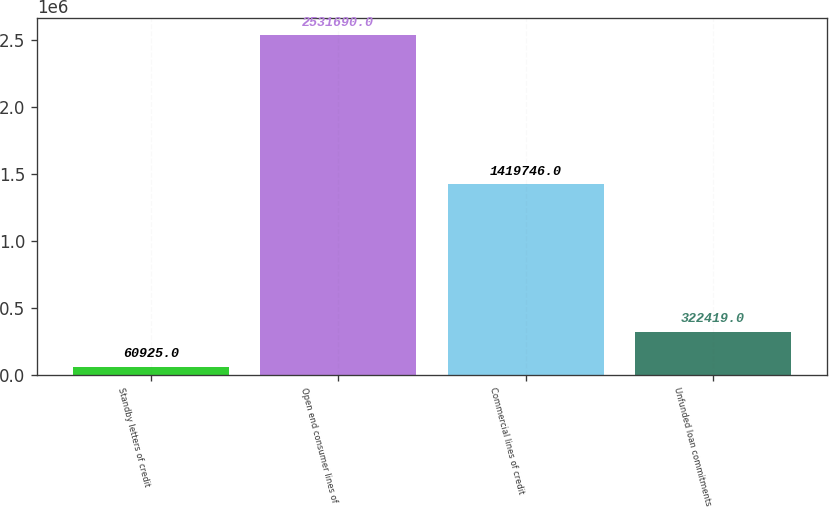Convert chart to OTSL. <chart><loc_0><loc_0><loc_500><loc_500><bar_chart><fcel>Standby letters of credit<fcel>Open end consumer lines of<fcel>Commercial lines of credit<fcel>Unfunded loan commitments<nl><fcel>60925<fcel>2.53169e+06<fcel>1.41975e+06<fcel>322419<nl></chart> 